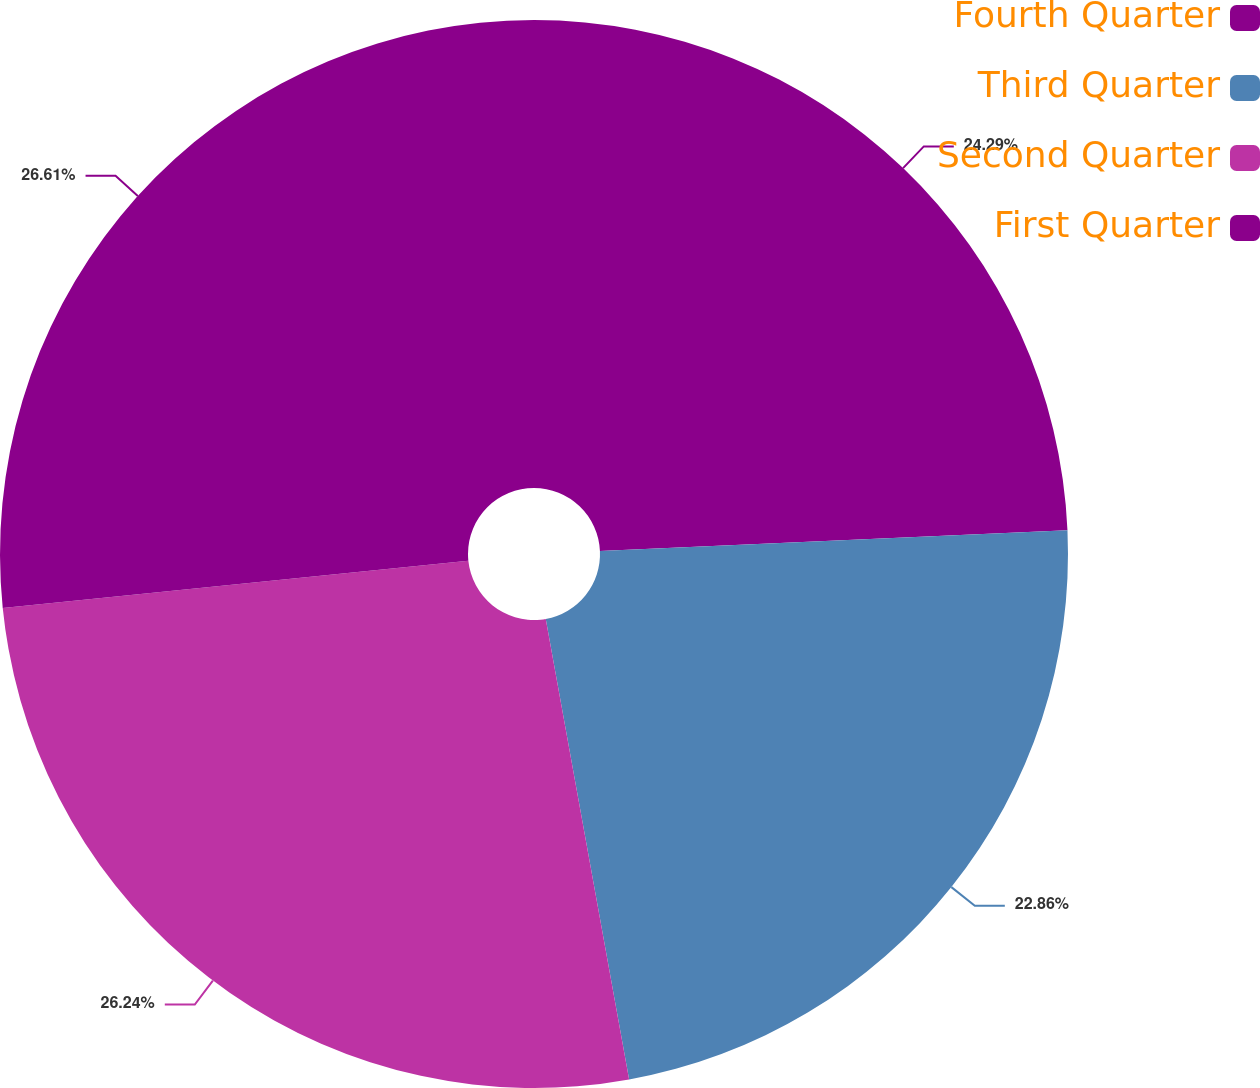<chart> <loc_0><loc_0><loc_500><loc_500><pie_chart><fcel>Fourth Quarter<fcel>Third Quarter<fcel>Second Quarter<fcel>First Quarter<nl><fcel>24.29%<fcel>22.86%<fcel>26.24%<fcel>26.61%<nl></chart> 